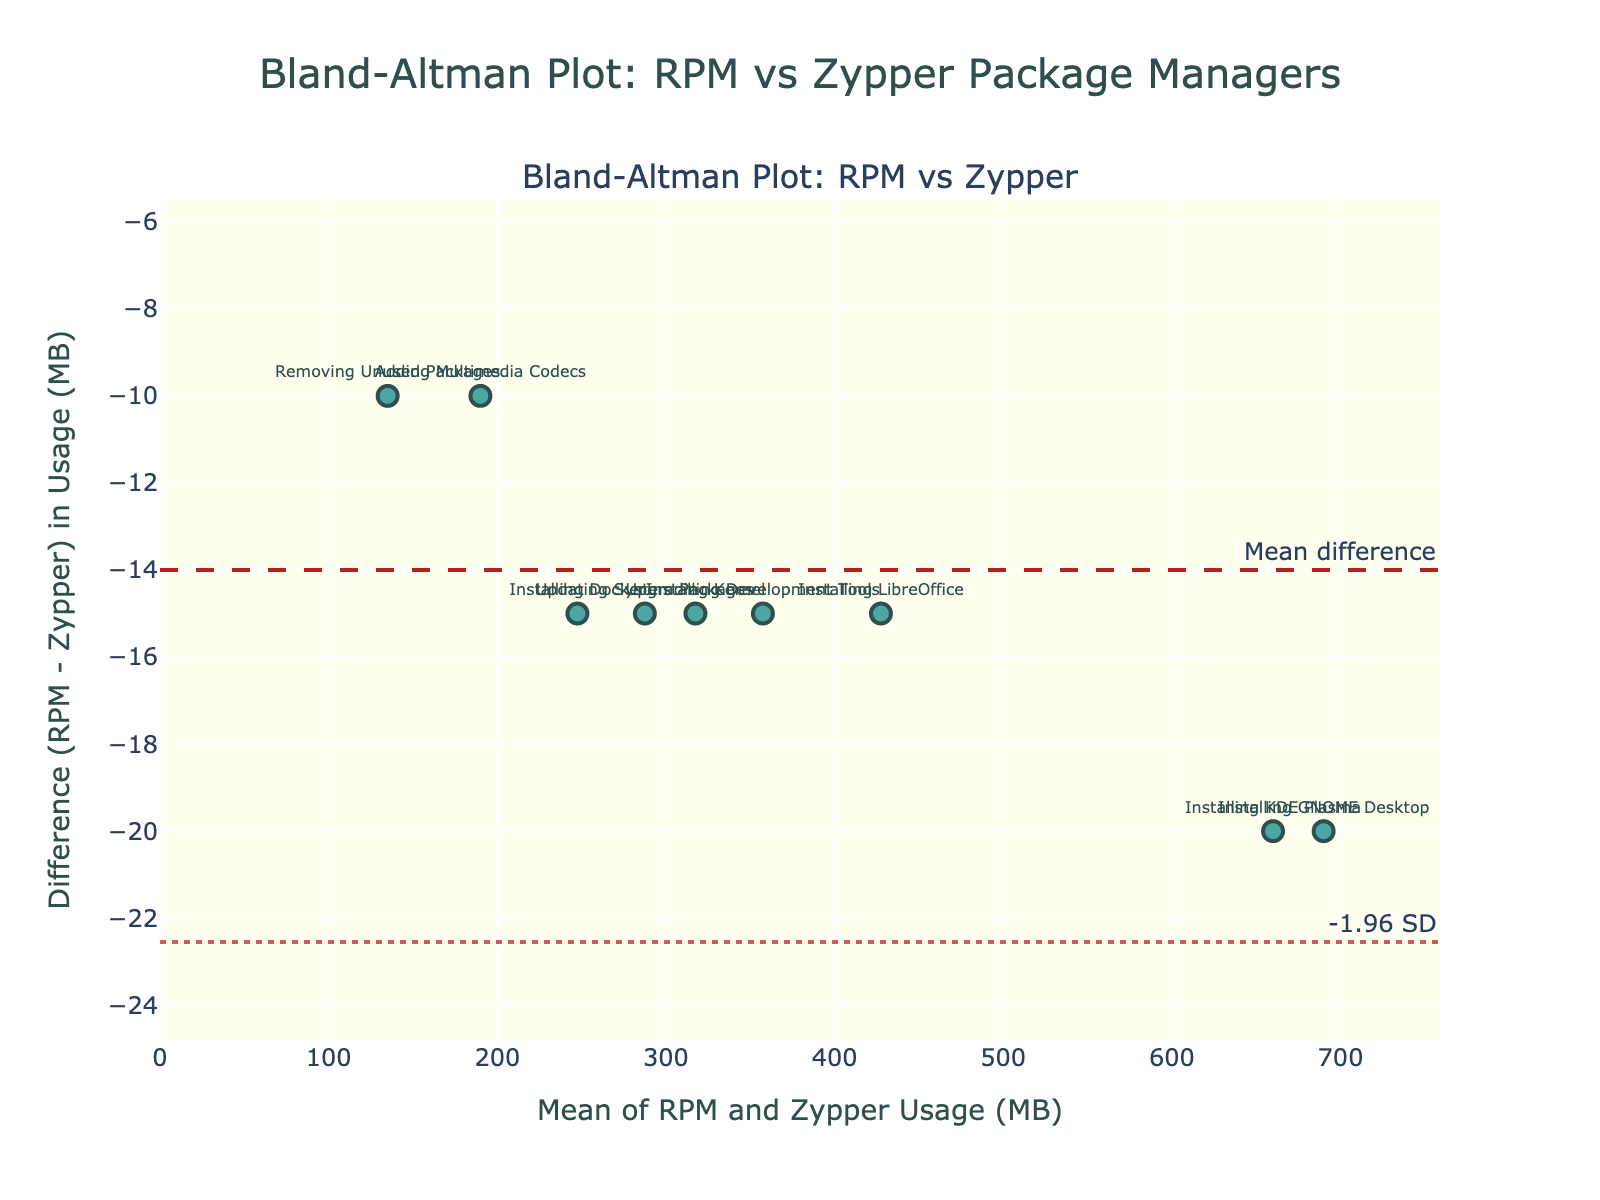What's the title of the plot? The title of the Bland-Altman plot is clearly visible at the top center of the plot. It is usually displayed in a larger and prominent font.
Answer: Bland-Altman Plot: RPM vs Zypper Package Managers What do the x-axis and y-axis represent? The x-axis represents the average usage (MB) of RPM and Zypper, and the y-axis represents the difference in usage (MB) between RPM and Zypper. This information is indicated by the axis titles.
Answer: x-axis: Average Usage (MB), y-axis: Difference in Usage (MB) Describe the color and style of the markers used in the scatter plot. The markers are a teal color with a semi-transparent appearance (suggested by "rgba(0, 128, 128, 0.7)" in the code). They have a dark grey outline which makes them distinctive against the background.
Answer: Teal with dark grey outline How many data points are there in the plot? Based on the data provided, each state or action (Initial System State, Installing LibreOffice, etc.) represents one data point, and there are 10 entries in the dataset. Thus, the plot shows 10 data points.
Answer: 10 Which measurement shows the maximum average usage, and what’s the corresponding difference? By examining the Bland-Altman plot, the measurement with the highest average usage will be the point farthest to the right on the x-axis. "Installing GNOME Desktop" shows the maximum average usage of 690 MB, and its difference (y-axis) can be read directly from the plot.
Answer: Installing GNOME Desktop, 20 MB Calculate the mean difference in usage (MB) between RPM and Zypper package managers. The mean difference is shown as a horizontal dashed line annotated as 'Mean difference'. It can be visually identified by its distinct line style and annotation.
Answer: 15.5 MB Which data point exhibits the largest difference (absolute value) between RPM and Zypper usage? The largest difference can be identified by finding the data point farthest from the y=0 line. By comparing the distances from the mean difference and limits of agreement lines, "Installing LibreOffice" has the largest difference.
Answer: Installing LibreOffice What are the upper and lower limits of agreement in the plot? The limits of agreement are represented by the dashed-dot lines labeled as '+1.96 SD' and '-1.96 SD'. You can find these values from the y-coordinates of these lines.
Answer: Upper limit: 36.286, Lower limit: -5.286 Why might it be useful to compare the system resource usage between RPM and Zypper using a Bland-Altman plot? A Bland-Altman plot helps to visualize the agreement between two different measurement methods (RPM and Zypper in this case). It shows the differences relative to the average of the two methods, making it easy to see both systematic differences (if any) and outliers.
Answer: To visualize agreement and identify systematic differences Which data points fall outside the limits of agreement and what might that indicate? Data points outside the limits of agreement lie outside the dashed-dot lines, indicating significant differences between the two package managers for those operations. "Installing LibreOffice" falls outside the upper limit, suggesting a considerable discrepancy in resource usage for this task between RPM and Zypper.
Answer: Installing LibreOffice 